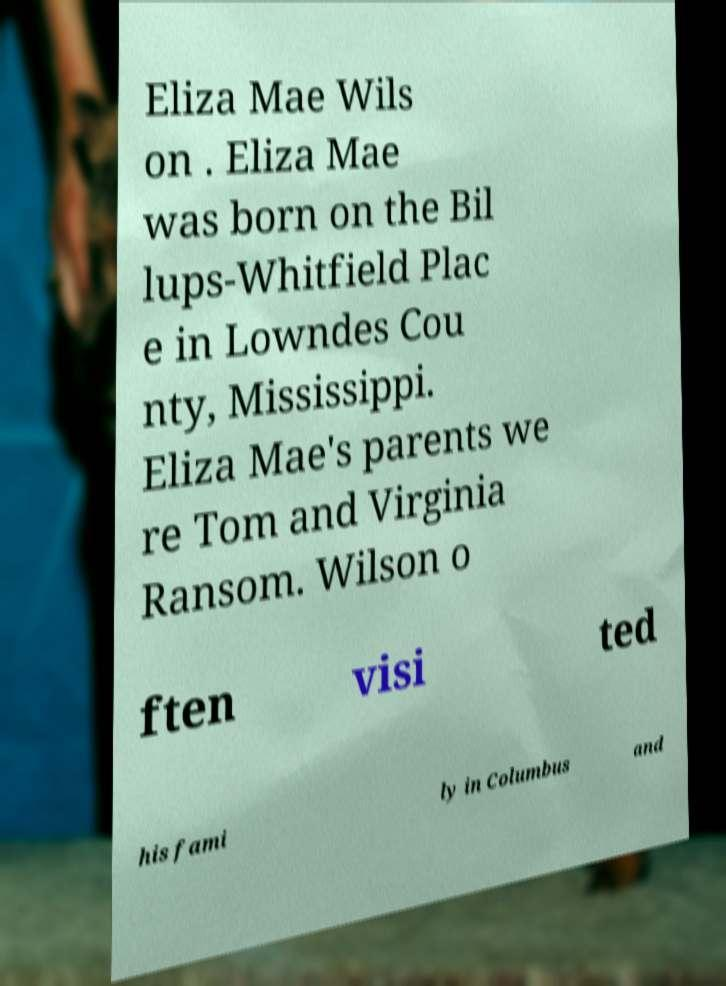Can you read and provide the text displayed in the image?This photo seems to have some interesting text. Can you extract and type it out for me? Eliza Mae Wils on . Eliza Mae was born on the Bil lups-Whitfield Plac e in Lowndes Cou nty, Mississippi. Eliza Mae's parents we re Tom and Virginia Ransom. Wilson o ften visi ted his fami ly in Columbus and 